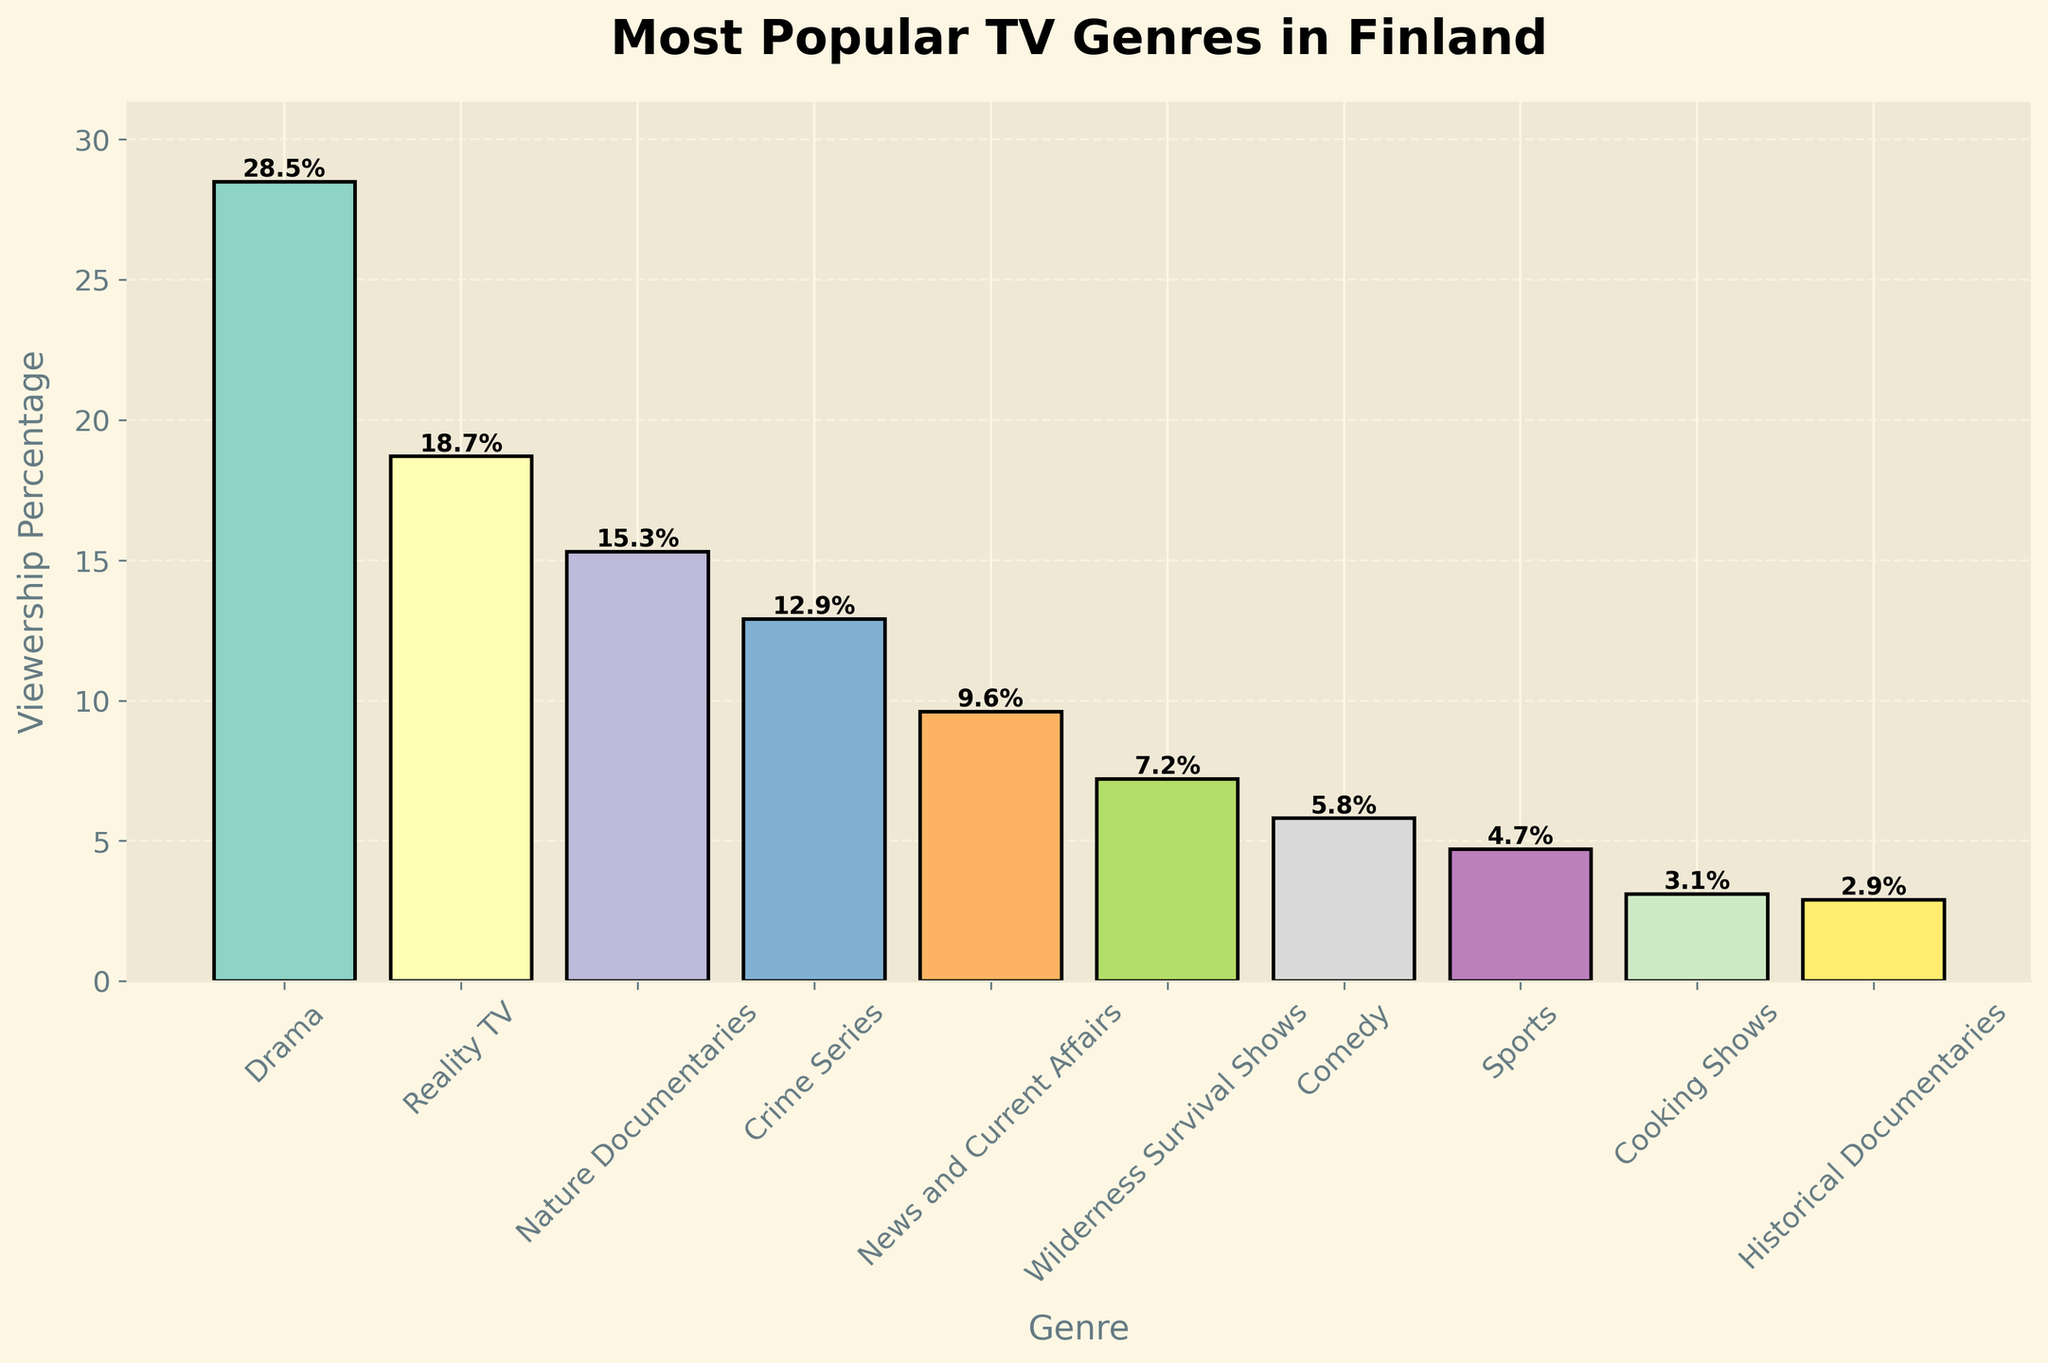What’s the most popular TV genre? The highest bar represents the most popular genre, which is Drama.
Answer: Drama Which TV genre has the lowest viewership percentage? The shortest bar represents the genre with the lowest viewership, which is Historical Documentaries.
Answer: Historical Documentaries How much higher is the viewership percentage of Drama compared to Sports? Drama has a viewership of 28.5% and Sports has 4.7%. Subtracting the two: 28.5% - 4.7% = 23.8%.
Answer: 23.8% What is the combined viewership percentage of Nature Documentaries and Wilderness Survival Shows? Nature Documentaries have 15.3% and Wilderness Survival Shows have 7.2%. Adding the two: 15.3% + 7.2% = 22.5%.
Answer: 22.5% Which genre has a higher viewership, Crime Series or News and Current Affairs? By comparing the heights of the bars, Crime Series has a higher viewership at 12.9% compared to News and Current Affairs at 9.6%.
Answer: Crime Series What is the average viewership percentage of Reality TV, Crime Series, and Comedy? Adding the percentages of Reality TV (18.7%), Crime Series (12.9%), and Comedy (5.8%): 18.7% + 12.9% + 5.8% = 37.4%. Then, dividing by 3: 37.4% / 3 ≈ 12.5%.
Answer: 12.5% Which genres have more than double the viewership percentage of Cooking Shows? Cooking Shows have a viewership of 3.1%. Double this is 6.2%. Genres above 6.2% are Drama, Reality TV, Nature Documentaries, Crime Series, News and Current Affairs, and Wilderness Survival Shows.
Answer: Drama, Reality TV, Nature Documentaries, Crime Series, News and Current Affairs, Wilderness Survival Shows What is the difference in viewership percentage between Nature Documentaries and Comedy? Nature Documentaries have 15.3%, and Comedy has 5.8%. Subtracting the two: 15.3% - 5.8% = 9.5%.
Answer: 9.5% What percentage of the total viewership do Reality TV and News and Current Affairs together represent? Reality TV has 18.7% and News and Current Affairs have 9.6%. Adding the two: 18.7% + 9.6% = 28.3%.
Answer: 28.3% 